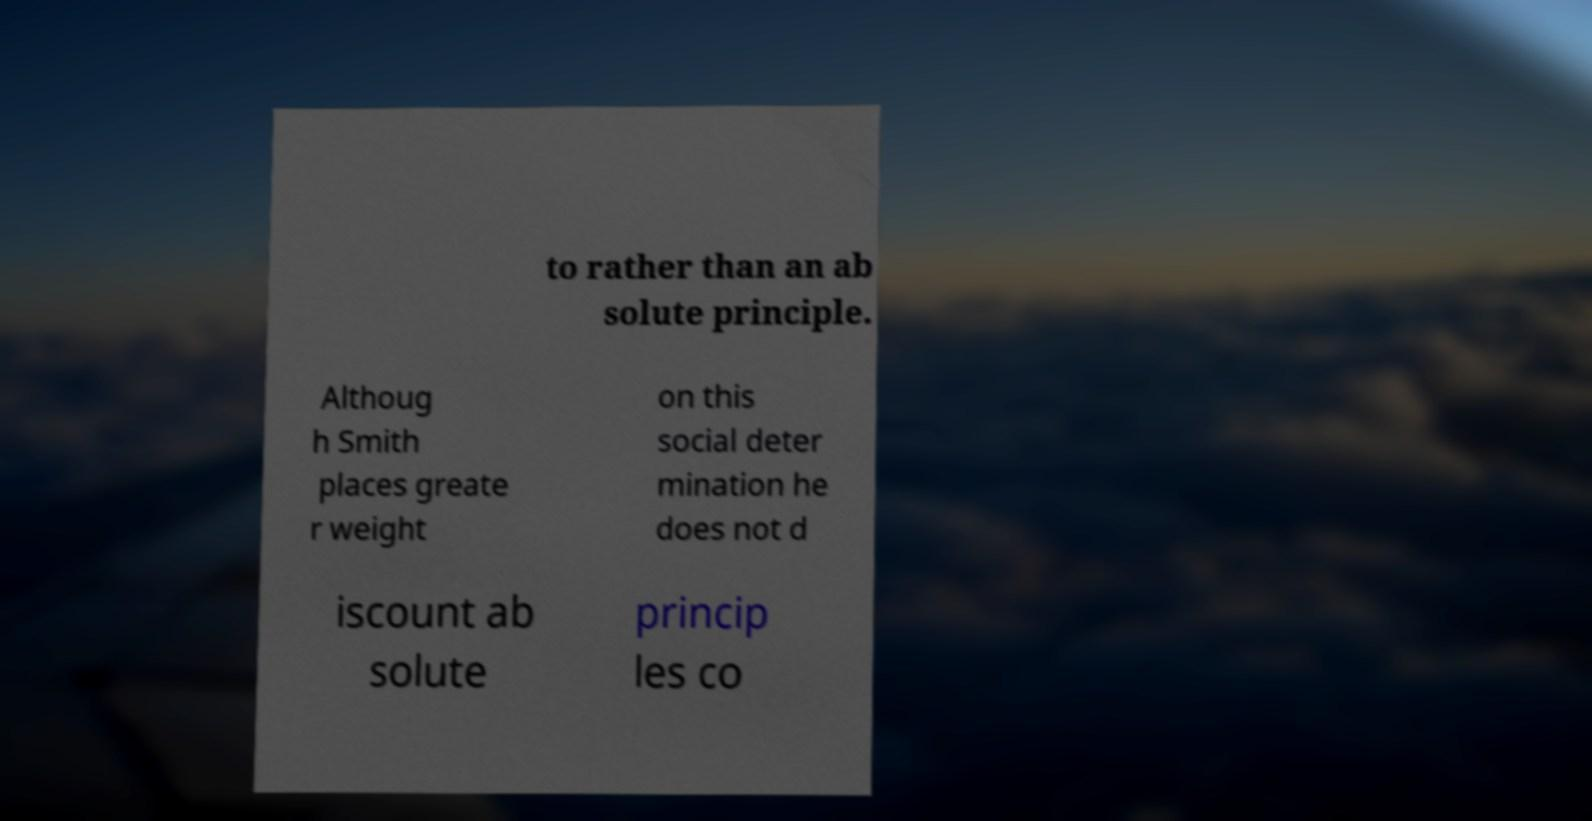Can you accurately transcribe the text from the provided image for me? to rather than an ab solute principle. Althoug h Smith places greate r weight on this social deter mination he does not d iscount ab solute princip les co 